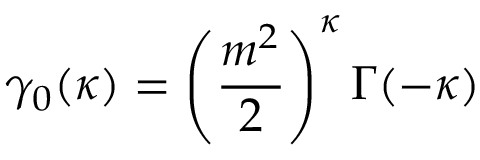Convert formula to latex. <formula><loc_0><loc_0><loc_500><loc_500>\gamma _ { 0 } ( \kappa ) = \left ( \frac { m ^ { 2 } } { 2 } \right ) ^ { \kappa } \Gamma ( - \kappa )</formula> 